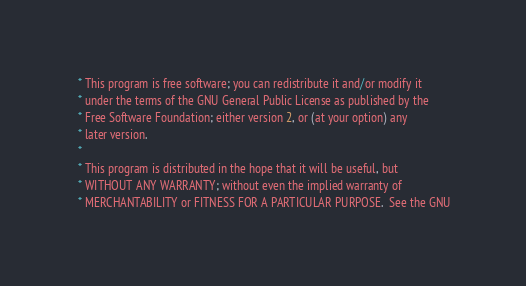Convert code to text. <code><loc_0><loc_0><loc_500><loc_500><_C_> * This program is free software; you can redistribute it and/or modify it
 * under the terms of the GNU General Public License as published by the
 * Free Software Foundation; either version 2, or (at your option) any
 * later version.
 *
 * This program is distributed in the hope that it will be useful, but
 * WITHOUT ANY WARRANTY; without even the implied warranty of
 * MERCHANTABILITY or FITNESS FOR A PARTICULAR PURPOSE.  See the GNU</code> 